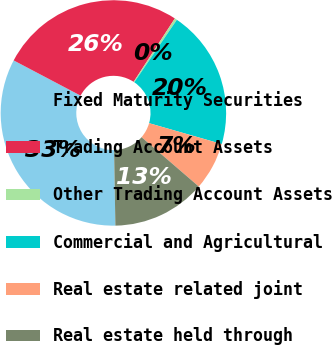Convert chart. <chart><loc_0><loc_0><loc_500><loc_500><pie_chart><fcel>Fixed Maturity Securities<fcel>Trading Account Assets<fcel>Other Trading Account Assets<fcel>Commercial and Agricultural<fcel>Real estate related joint<fcel>Real estate held through<nl><fcel>32.99%<fcel>26.46%<fcel>0.34%<fcel>19.93%<fcel>6.87%<fcel>13.4%<nl></chart> 